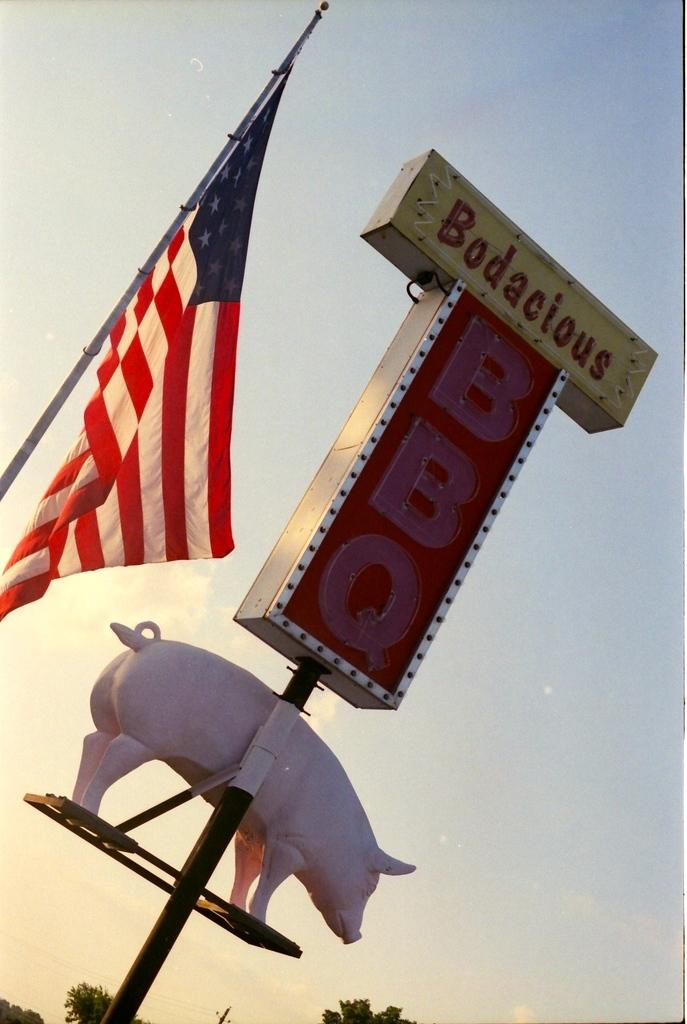What is the main subject of the image? There is a statue of a pig in the image. What else can be seen in the image besides the pig statue? There is a board in the image. What can be seen in the background of the image? There are trees, a flag, and the sky visible in the background of the image. Can you hear the guitar being played in the image? There is no guitar present in the image, so it cannot be heard or played. 